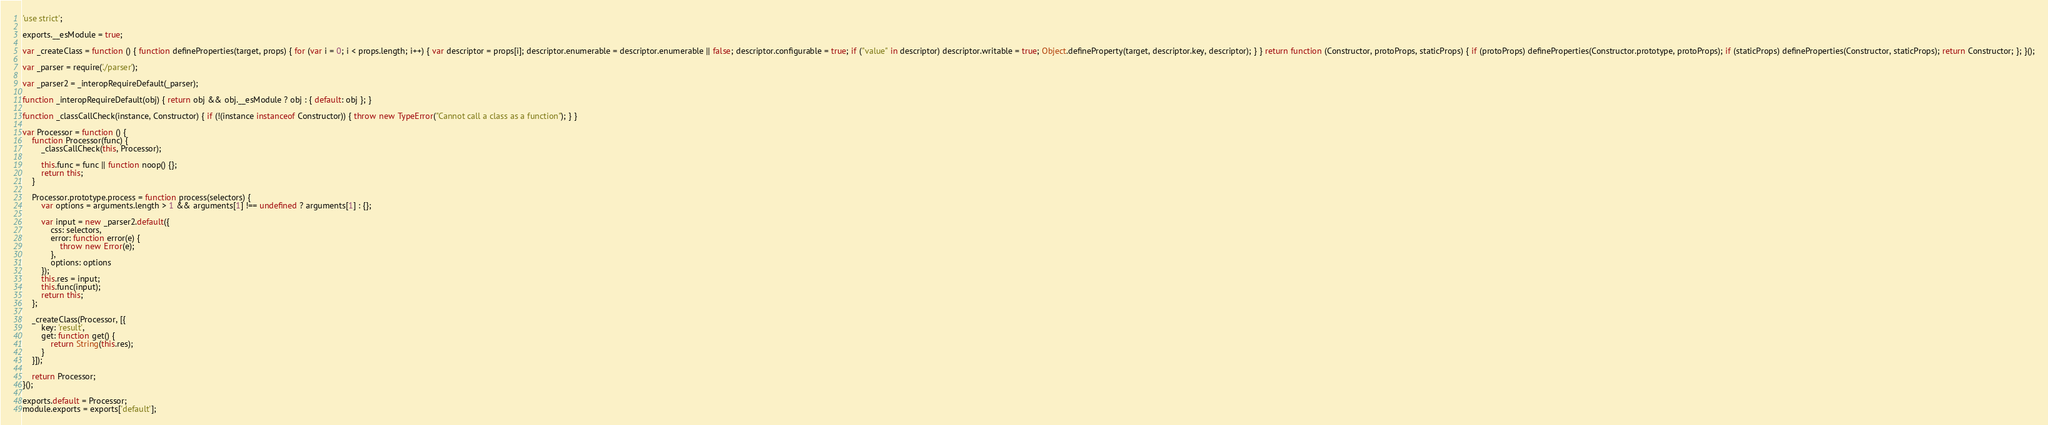Convert code to text. <code><loc_0><loc_0><loc_500><loc_500><_JavaScript_>'use strict';

exports.__esModule = true;

var _createClass = function () { function defineProperties(target, props) { for (var i = 0; i < props.length; i++) { var descriptor = props[i]; descriptor.enumerable = descriptor.enumerable || false; descriptor.configurable = true; if ("value" in descriptor) descriptor.writable = true; Object.defineProperty(target, descriptor.key, descriptor); } } return function (Constructor, protoProps, staticProps) { if (protoProps) defineProperties(Constructor.prototype, protoProps); if (staticProps) defineProperties(Constructor, staticProps); return Constructor; }; }();

var _parser = require('./parser');

var _parser2 = _interopRequireDefault(_parser);

function _interopRequireDefault(obj) { return obj && obj.__esModule ? obj : { default: obj }; }

function _classCallCheck(instance, Constructor) { if (!(instance instanceof Constructor)) { throw new TypeError("Cannot call a class as a function"); } }

var Processor = function () {
    function Processor(func) {
        _classCallCheck(this, Processor);

        this.func = func || function noop() {};
        return this;
    }

    Processor.prototype.process = function process(selectors) {
        var options = arguments.length > 1 && arguments[1] !== undefined ? arguments[1] : {};

        var input = new _parser2.default({
            css: selectors,
            error: function error(e) {
                throw new Error(e);
            },
            options: options
        });
        this.res = input;
        this.func(input);
        return this;
    };

    _createClass(Processor, [{
        key: 'result',
        get: function get() {
            return String(this.res);
        }
    }]);

    return Processor;
}();

exports.default = Processor;
module.exports = exports['default'];</code> 